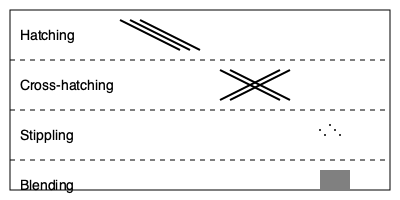Which shading technique is most effective for creating a smooth gradient of tones and is often used to represent soft textures or skin? Let's analyze each shading technique shown in the image:

1. Hatching: This technique uses parallel lines to create shading. It's effective for creating texture but not ideal for smooth gradients.

2. Cross-hatching: This involves layering sets of parallel lines at different angles. It creates more depth than hatching but still has a distinct texture.

3. Stippling: This technique uses small dots to create shading. It can create smooth gradients but is time-consuming and not typically used for large areas.

4. Blending: This technique involves smoothly transitioning between tones, often using tools like blending stumps or fingers. It creates the smoothest gradients and is ideal for soft textures.

For creating smooth gradients and representing soft textures or skin, blending is the most effective technique. It allows for seamless transitions between light and dark areas, which is crucial for depicting the subtle variations in skin tone and the soft appearance of skin.
Answer: Blending 